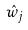Convert formula to latex. <formula><loc_0><loc_0><loc_500><loc_500>\hat { w } _ { j }</formula> 